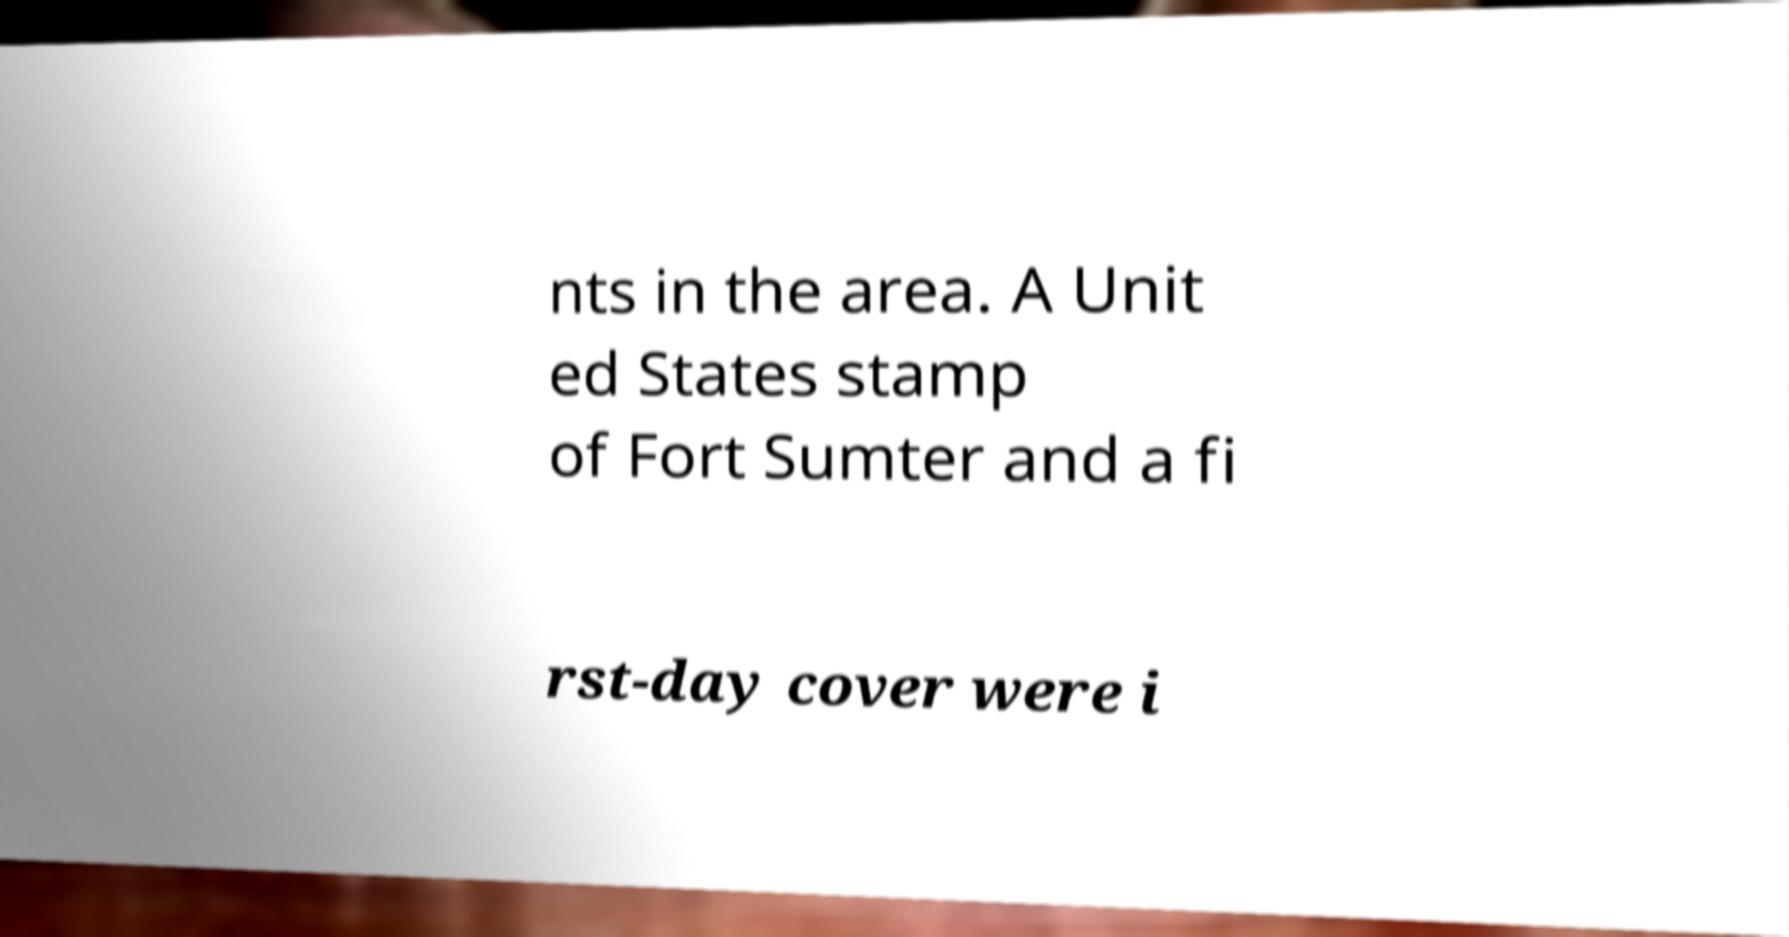I need the written content from this picture converted into text. Can you do that? nts in the area. A Unit ed States stamp of Fort Sumter and a fi rst-day cover were i 